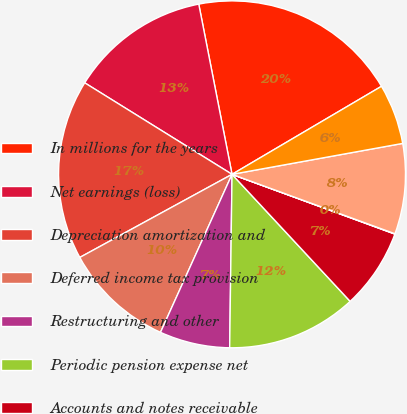Convert chart to OTSL. <chart><loc_0><loc_0><loc_500><loc_500><pie_chart><fcel>In millions for the years<fcel>Net earnings (loss)<fcel>Depreciation amortization and<fcel>Deferred income tax provision<fcel>Restructuring and other<fcel>Periodic pension expense net<fcel>Accounts and notes receivable<fcel>Inventories<fcel>Accounts payable and accrued<fcel>Interest payable<nl><fcel>19.6%<fcel>13.08%<fcel>16.8%<fcel>10.28%<fcel>6.55%<fcel>12.14%<fcel>7.48%<fcel>0.03%<fcel>8.42%<fcel>5.62%<nl></chart> 